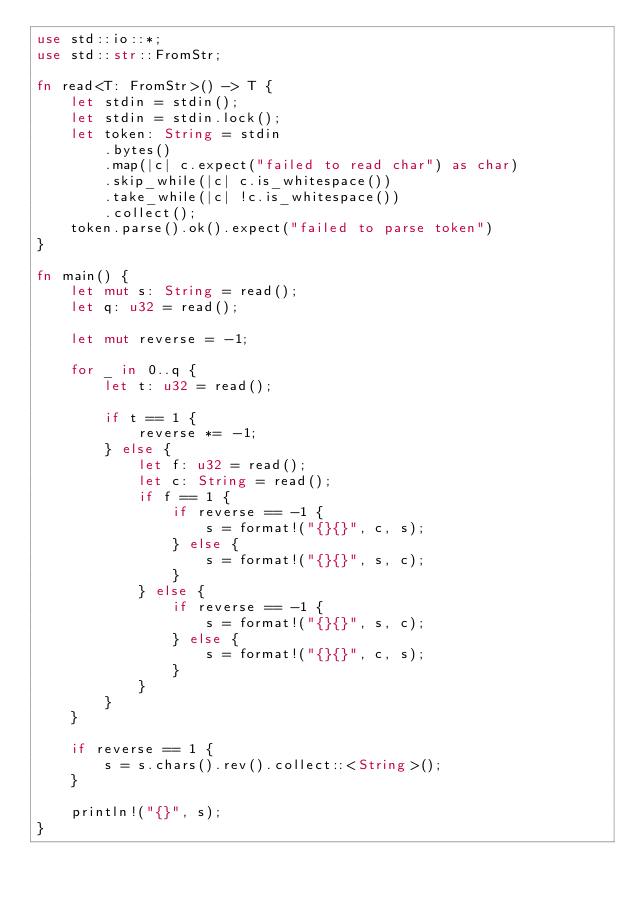<code> <loc_0><loc_0><loc_500><loc_500><_Rust_>use std::io::*;
use std::str::FromStr;

fn read<T: FromStr>() -> T {
    let stdin = stdin();
    let stdin = stdin.lock();
    let token: String = stdin
        .bytes()
        .map(|c| c.expect("failed to read char") as char) 
        .skip_while(|c| c.is_whitespace())
        .take_while(|c| !c.is_whitespace())
        .collect();
    token.parse().ok().expect("failed to parse token")
}

fn main() {
    let mut s: String = read();
    let q: u32 = read();

    let mut reverse = -1;

    for _ in 0..q {
        let t: u32 = read();

        if t == 1 {
            reverse *= -1;
        } else {
            let f: u32 = read();
            let c: String = read();
            if f == 1 {
                if reverse == -1 {
                    s = format!("{}{}", c, s);
                } else {
                    s = format!("{}{}", s, c);
                }
            } else {
                if reverse == -1 {
                    s = format!("{}{}", s, c);
                } else {
                    s = format!("{}{}", c, s);
                }
            }
        }
    }

    if reverse == 1 {
        s = s.chars().rev().collect::<String>();
    }

    println!("{}", s);
}
</code> 